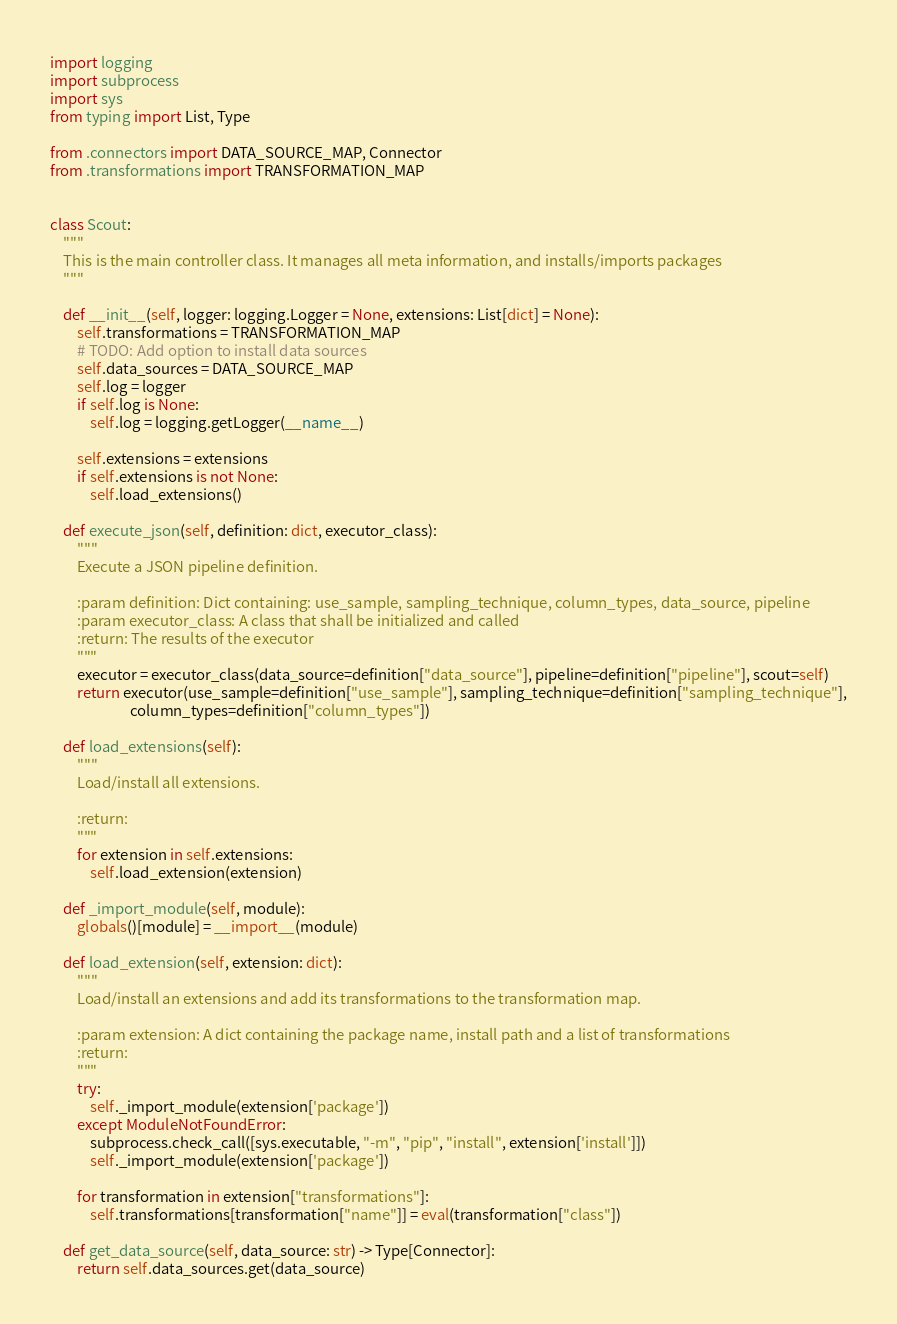<code> <loc_0><loc_0><loc_500><loc_500><_Python_>import logging
import subprocess
import sys
from typing import List, Type

from .connectors import DATA_SOURCE_MAP, Connector
from .transformations import TRANSFORMATION_MAP


class Scout:
    """
    This is the main controller class. It manages all meta information, and installs/imports packages
    """

    def __init__(self, logger: logging.Logger = None, extensions: List[dict] = None):
        self.transformations = TRANSFORMATION_MAP
        # TODO: Add option to install data sources
        self.data_sources = DATA_SOURCE_MAP
        self.log = logger
        if self.log is None:
            self.log = logging.getLogger(__name__)

        self.extensions = extensions
        if self.extensions is not None:
            self.load_extensions()

    def execute_json(self, definition: dict, executor_class):
        """
        Execute a JSON pipeline definition.

        :param definition: Dict containing: use_sample, sampling_technique, column_types, data_source, pipeline
        :param executor_class: A class that shall be initialized and called
        :return: The results of the executor
        """
        executor = executor_class(data_source=definition["data_source"], pipeline=definition["pipeline"], scout=self)
        return executor(use_sample=definition["use_sample"], sampling_technique=definition["sampling_technique"],
                        column_types=definition["column_types"])

    def load_extensions(self):
        """
        Load/install all extensions.

        :return:
        """
        for extension in self.extensions:
            self.load_extension(extension)

    def _import_module(self, module):
        globals()[module] = __import__(module)

    def load_extension(self, extension: dict):
        """
        Load/install an extensions and add its transformations to the transformation map.

        :param extension: A dict containing the package name, install path and a list of transformations
        :return:
        """
        try:
            self._import_module(extension['package'])
        except ModuleNotFoundError:
            subprocess.check_call([sys.executable, "-m", "pip", "install", extension['install']])
            self._import_module(extension['package'])

        for transformation in extension["transformations"]:
            self.transformations[transformation["name"]] = eval(transformation["class"])

    def get_data_source(self, data_source: str) -> Type[Connector]:
        return self.data_sources.get(data_source)
</code> 